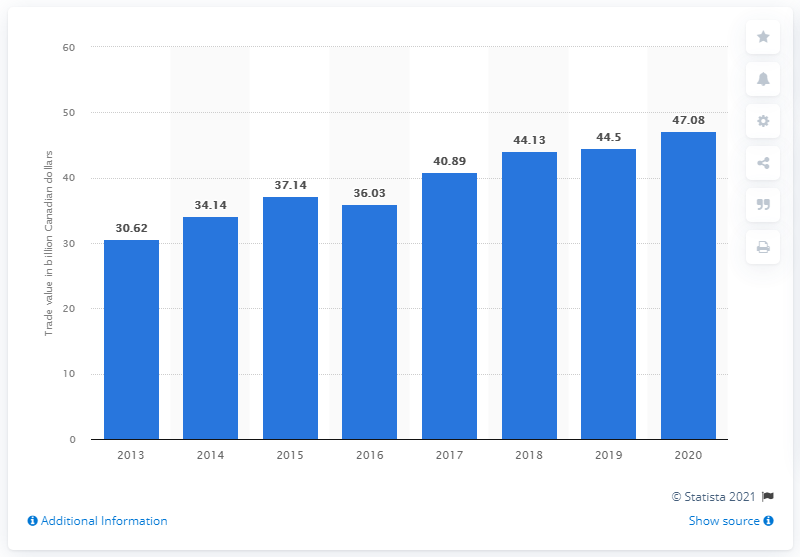Specify some key components in this picture. In 2010, the value of imports from China to Canada was $44.5 billion. In 2020, the value of imports from China to Canada was CAD 47.08 billion. 